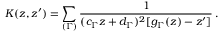<formula> <loc_0><loc_0><loc_500><loc_500>K ( z , z ^ { \prime } ) = \sum _ { ( \Gamma ) } \frac { 1 } { ( c _ { \Gamma } z + d _ { \Gamma } ) ^ { 2 } [ g _ { \Gamma } ( z ) - z ^ { \prime } ] } \, .</formula> 